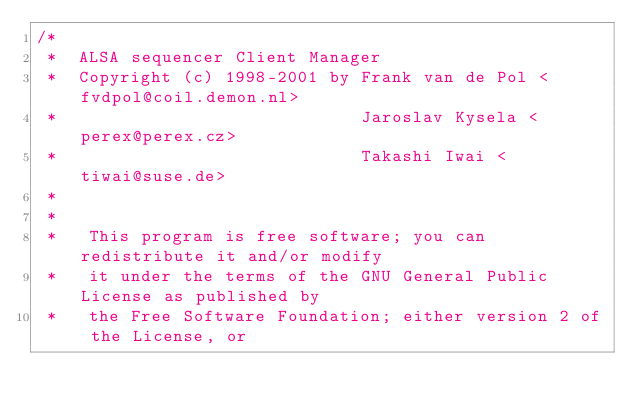<code> <loc_0><loc_0><loc_500><loc_500><_C_>/*
 *  ALSA sequencer Client Manager
 *  Copyright (c) 1998-2001 by Frank van de Pol <fvdpol@coil.demon.nl>
 *                             Jaroslav Kysela <perex@perex.cz>
 *                             Takashi Iwai <tiwai@suse.de>
 *
 *
 *   This program is free software; you can redistribute it and/or modify
 *   it under the terms of the GNU General Public License as published by
 *   the Free Software Foundation; either version 2 of the License, or</code> 